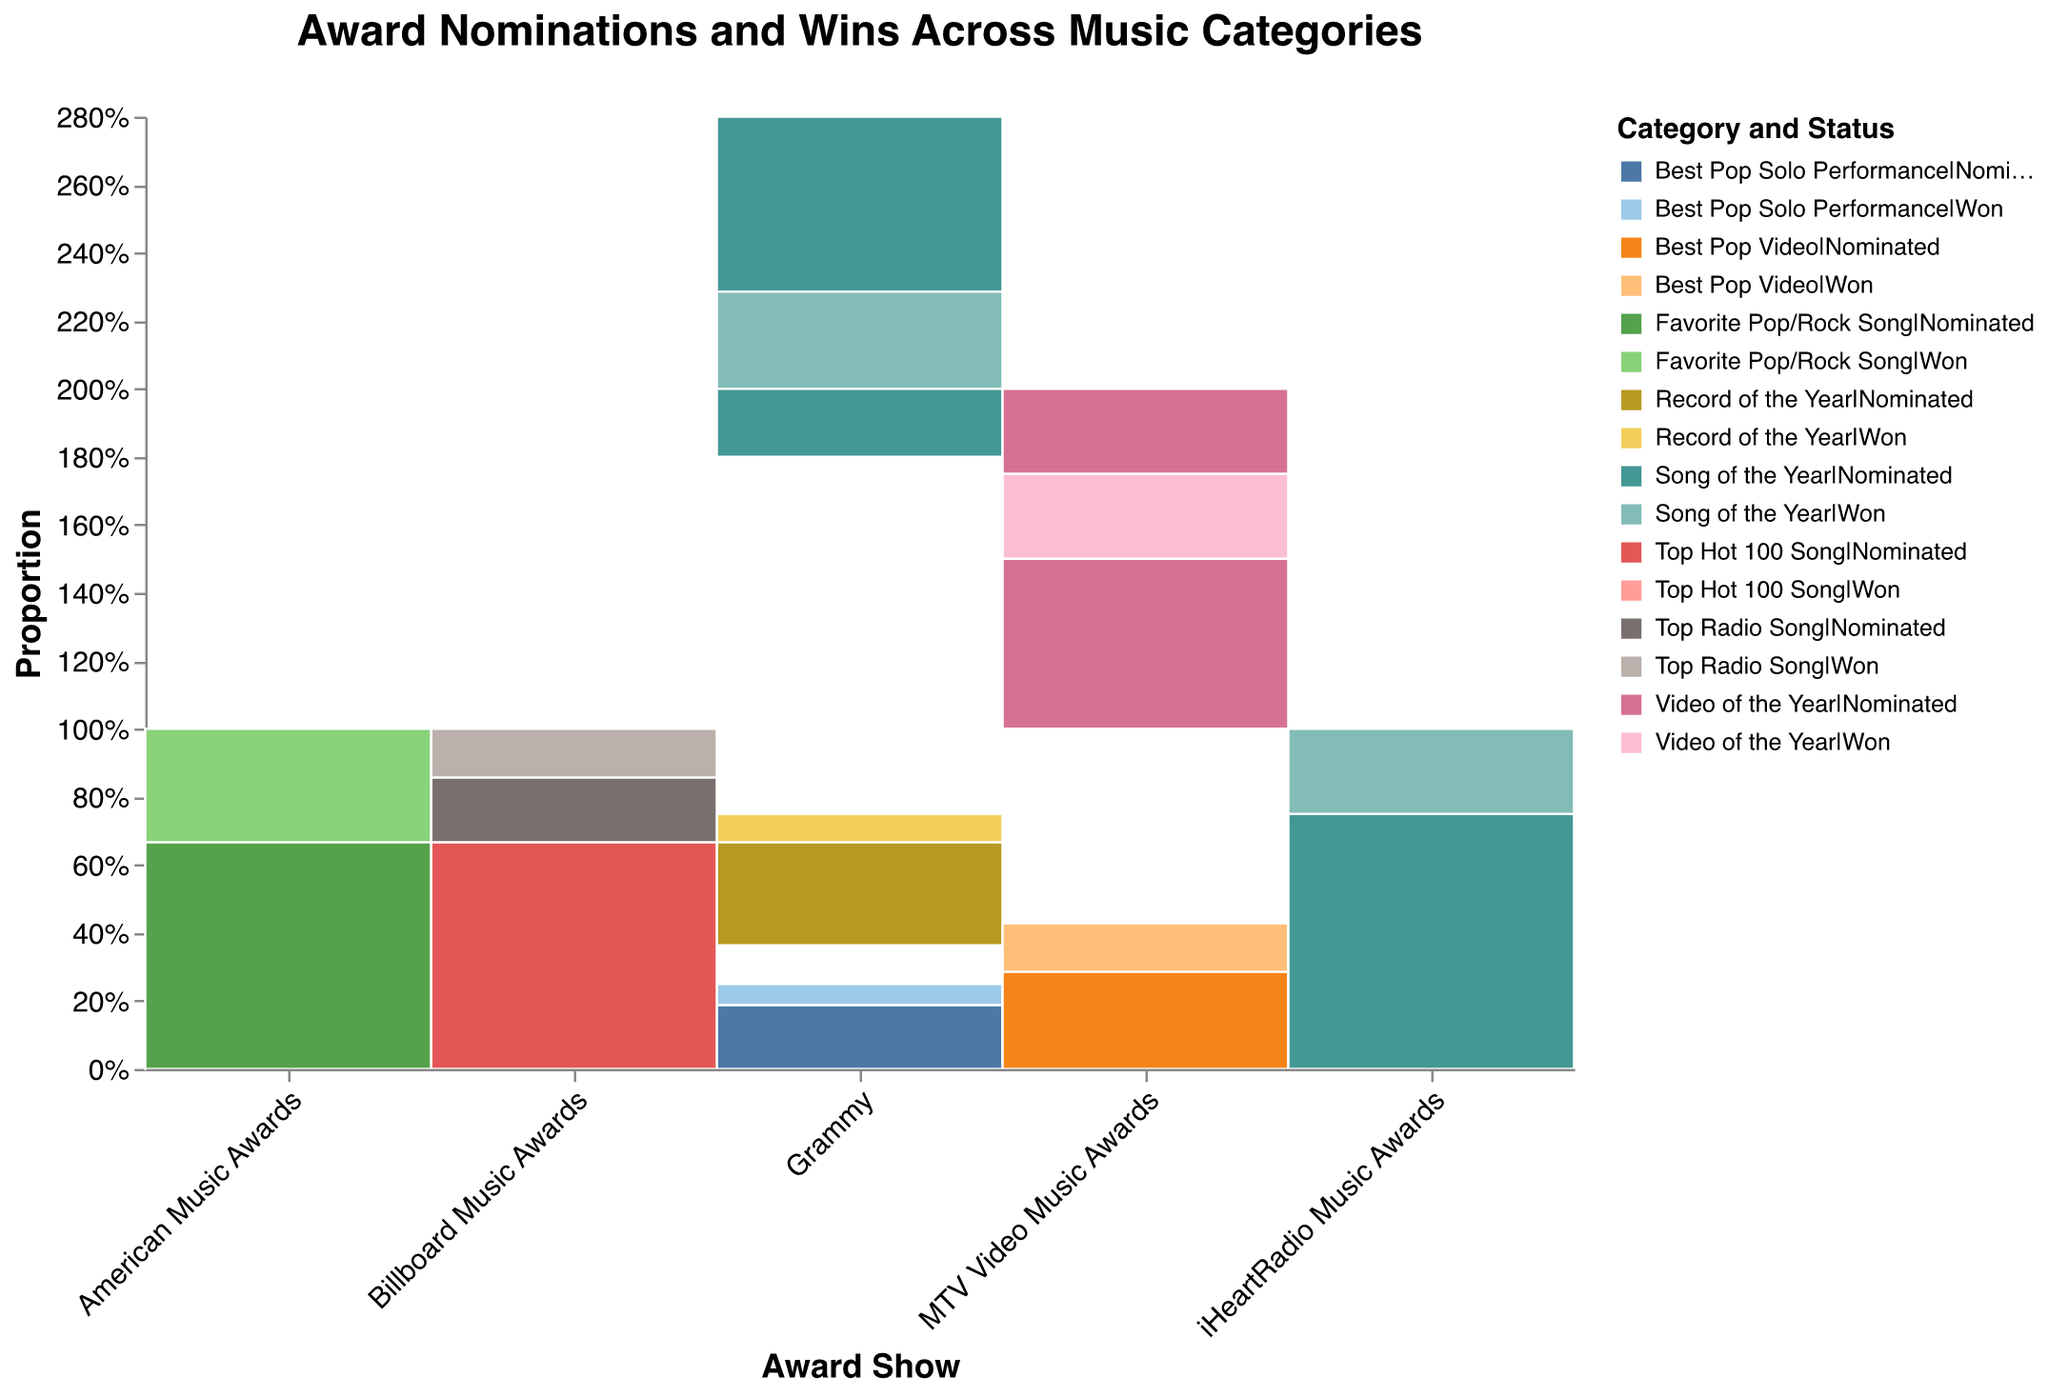What's the title of the figure? The title is located at the top of the figure, in bold and centered.
Answer: Award Nominations and Wins Across Music Categories How many categories are represented across all award shows? Count the unique category labels present in the colored legend.
Answer: 6 Which award show has the smallest total proportion for 'Top Radio Song'? Compare the 'Top Radio Song' segments in each award show by checking their proportions on the y-axis. The one with the smallest height is the smallest proportion.
Answer: Billboard Music Awards Which category has the most balanced ratio of nominations to wins for the Grammy Awards? Find the Grammy Award segments and compare the 'Nominated' and 'Won' sections for each category. The one with the most similar heights has the most balanced ratio.
Answer: Song of the Year Which award show has the most diverse set of categories? Compare the number of different categories (based on color variations) represented in each award show. The award show with the most unique colors has the most diverse set.
Answer: Grammy Do the Billboard Music Awards and iHeartRadio Music Awards have any overlapping categories? Look for color-coded categories in both the Billboard Music Awards and iHeartRadio Music Awards sections. Any matching colors represent overlapping categories.
Answer: Yes Which category has the highest total count of nominations and wins combined across all award shows? Add up the 'TotalCount' of nominations and wins for each category across all shows. The category with the highest sum is the answer.
Answer: Song of the Year 